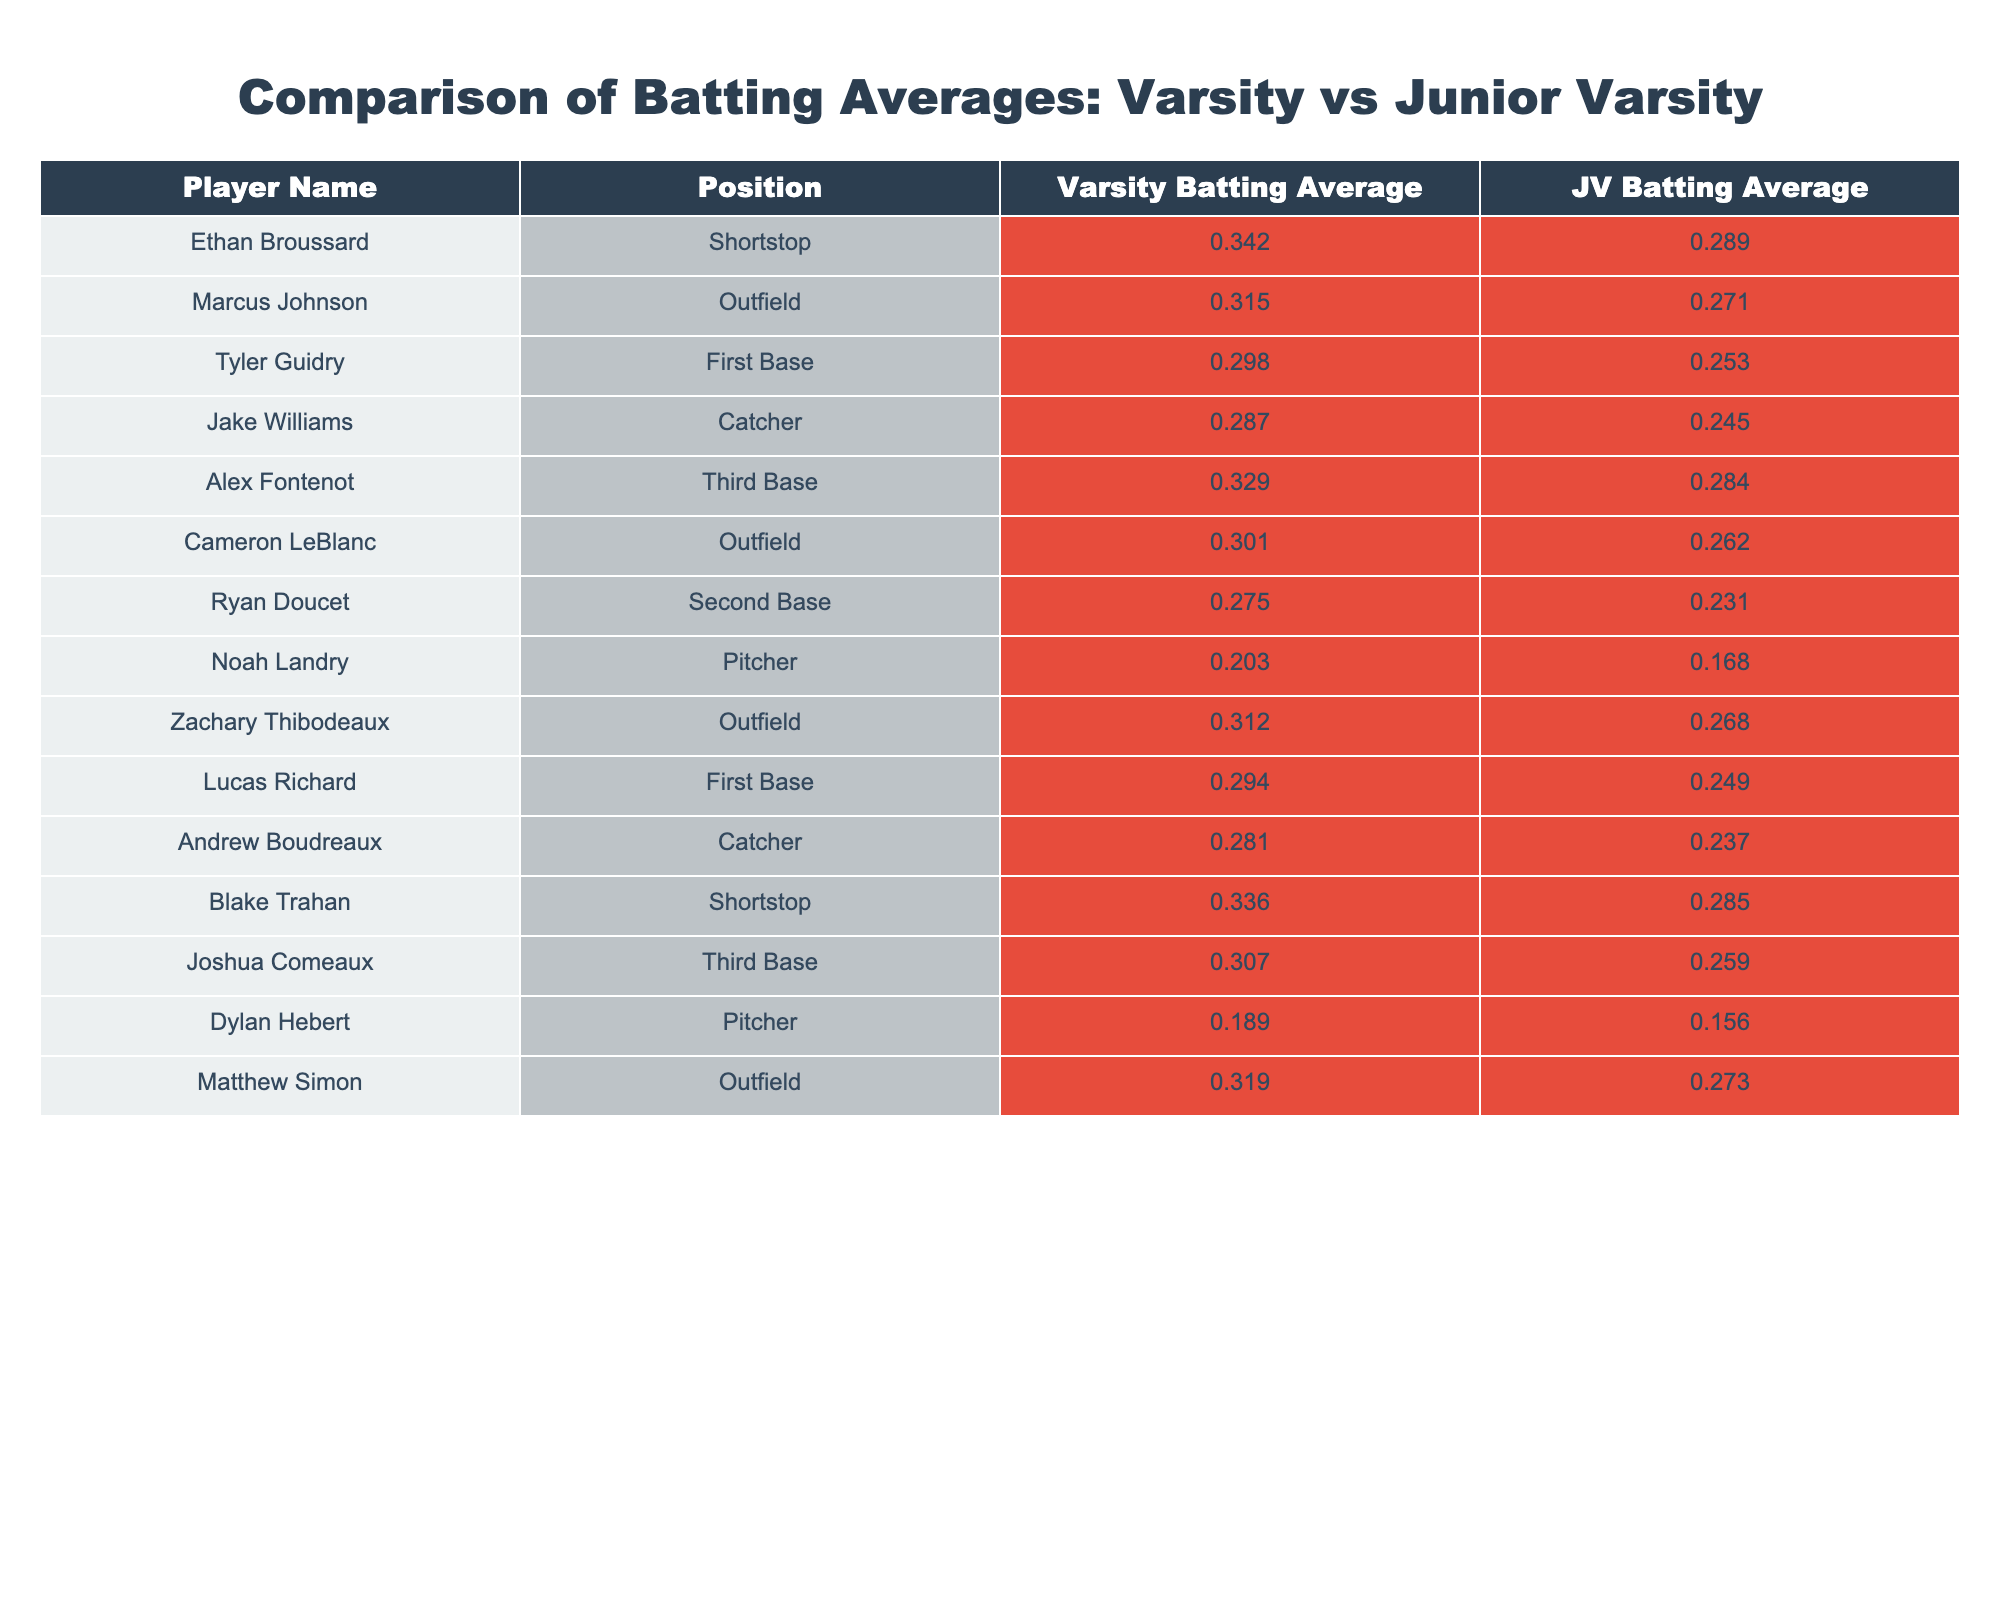What is the highest batting average among varsity players? The highest batting average can be found by looking through the "Varsity Batting Average" column. Scanning the values reveals that Ethan Broussard has the highest average of 0.342.
Answer: 0.342 What is the lowest batting average among junior varsity players? To find the lowest batting average in the "JV Batting Average" column, we compare all the values. The lowest average is held by Noah Landry with a value of 0.168.
Answer: 0.168 Which player has a greater difference between varsity and junior varsity averages? To calculate the largest difference, we subtract each player's JV average from their Varsity average. The maximum difference is found for Ryan Doucet, where the difference is 0.275 - 0.231 = 0.044. The player with the greatest difference is Tyler Guidry, with a difference of 0.298 - 0.253 = 0.045.
Answer: Tyler Guidry Are there any players whose varsity batting average is below their junior varsity average? By comparing the values in each row, we find that all varsity averages are higher than their corresponding junior varsity averages. Thus, there are no players with a lower average in varsity than in junior varsity.
Answer: No What is the average varsity batting average for all players listed? To calculate the average, we sum all the varsity batting averages: 0.342 + 0.315 + 0.298 + 0.287 + 0.329 + 0.301 + 0.275 + 0.203 + 0.312 + 0.294 + 0.281 + 0.336 + 0.307 + 0.319 = 4.188. We then divide by the number of players (14), giving us an average of approximately 0.2991.
Answer: 0.2991 Which position on the varsity team has the player with the highest batting average? Scanning through the "Position" column alongside the "Varsity Batting Average," we find that the shortstop position (Ethan Broussard) has the highest batting average of 0.342. Therefore, shortstop is the position with the player achieving the highest batting average.
Answer: Shortstop What is the total batting average of all junior varsity players? Adding together all of the junior varsity batting averages gives us the total: 0.289 + 0.271 + 0.253 + 0.245 + 0.284 + 0.262 + 0.231 + 0.168 + 0.268 + 0.249 + 0.237 + 0.285 + 0.259 + 0.273 = 3.531.
Answer: 3.531 How many players have a junior varsity batting average above 0.25? To determine how many junior varsity players exceed a batting average of 0.25, we check each value in the "JV Batting Average" column. The players with averages above 0.25 are: Ethan Broussard, Marcus Johnson, Tyler Guidry, Alex Fontenot, Cameron LeBlanc, Zachary Thibodeaux, and Matthew Simon. In total, there are 7 players.
Answer: 7 Which player has the closest varsity batting average to their junior varsity average? To find the player with the closest averages, we calculate the absolute differences between the varsity and junior varsity averages for each player. The smallest difference is for Ryan Doucet, with a difference of 0.044.
Answer: Ryan Doucet 